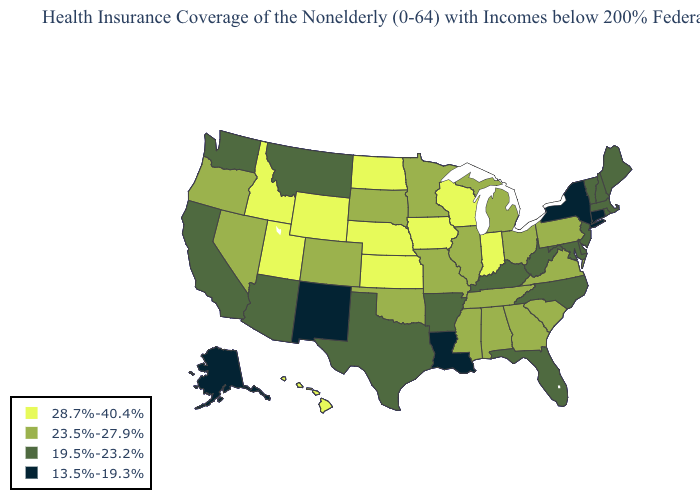What is the highest value in the USA?
Give a very brief answer. 28.7%-40.4%. Does the map have missing data?
Concise answer only. No. What is the value of Kentucky?
Quick response, please. 19.5%-23.2%. What is the value of Oregon?
Concise answer only. 23.5%-27.9%. Among the states that border Idaho , does Wyoming have the highest value?
Concise answer only. Yes. Among the states that border Minnesota , does Iowa have the lowest value?
Keep it brief. No. Among the states that border New Mexico , does Oklahoma have the lowest value?
Concise answer only. No. What is the highest value in the USA?
Answer briefly. 28.7%-40.4%. What is the lowest value in states that border South Dakota?
Keep it brief. 19.5%-23.2%. Name the states that have a value in the range 23.5%-27.9%?
Give a very brief answer. Alabama, Colorado, Georgia, Illinois, Michigan, Minnesota, Mississippi, Missouri, Nevada, Ohio, Oklahoma, Oregon, Pennsylvania, South Carolina, South Dakota, Tennessee, Virginia. Does the first symbol in the legend represent the smallest category?
Quick response, please. No. Which states hav the highest value in the Northeast?
Short answer required. Pennsylvania. Among the states that border Kansas , does Missouri have the highest value?
Short answer required. No. What is the value of Michigan?
Short answer required. 23.5%-27.9%. What is the value of Oregon?
Give a very brief answer. 23.5%-27.9%. 